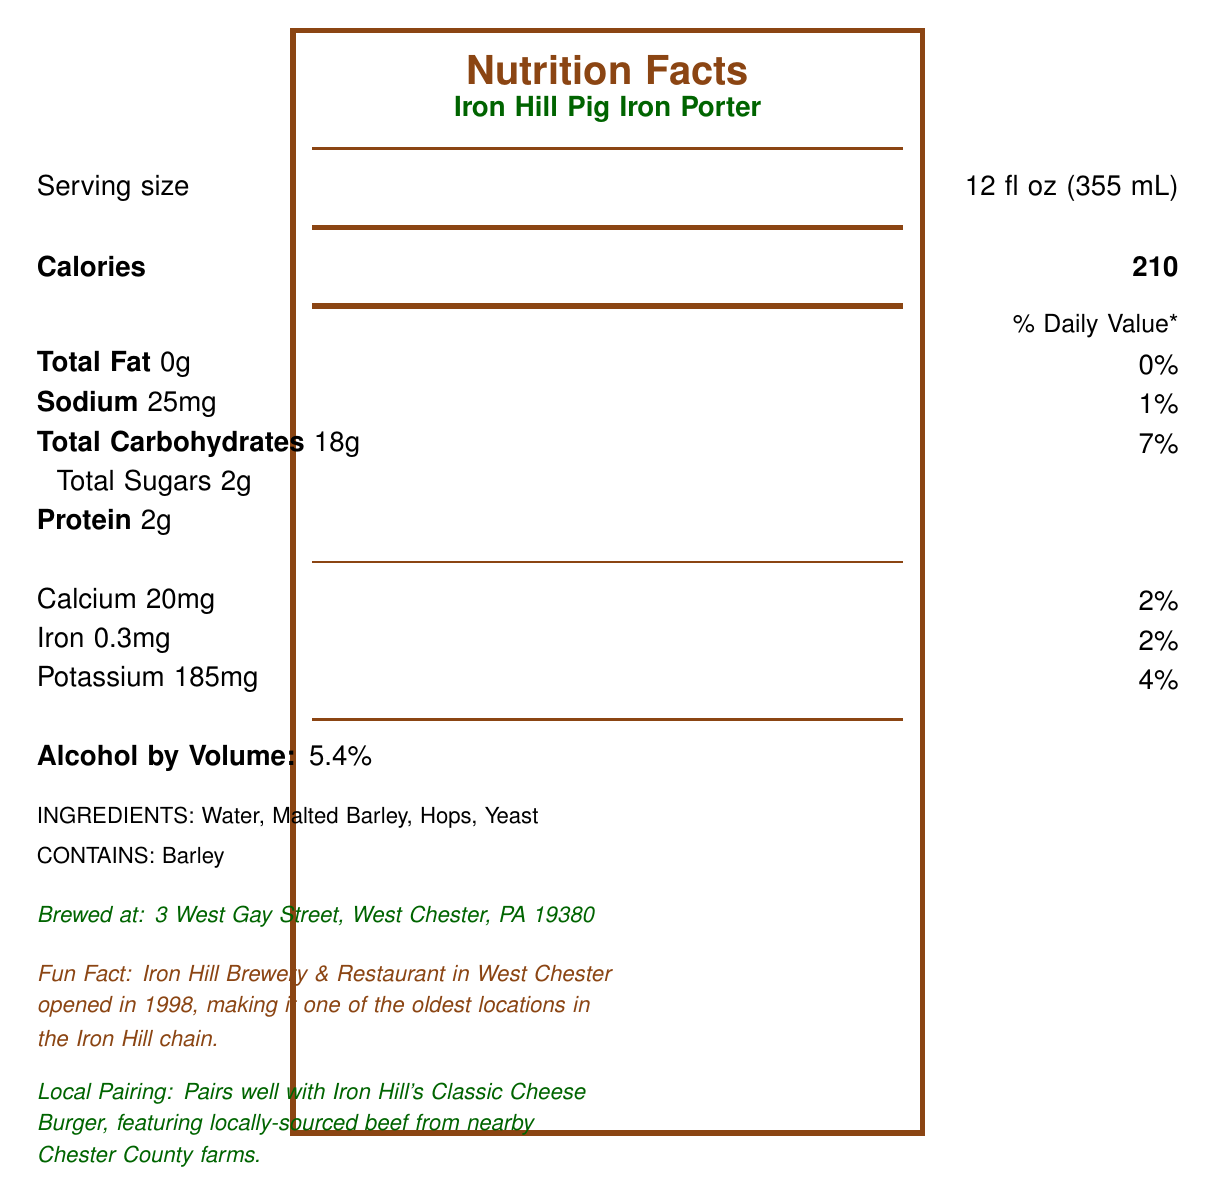What is the serving size of Iron Hill Pig Iron Porter? The serving size is explicitly mentioned in the document as "12 fl oz (355 mL)".
Answer: 12 fl oz (355 mL) How many calories are in one serving of Iron Hill Pig Iron Porter? The document states that there are 210 calories in one serving.
Answer: 210 What is the percentage of daily value for sodium? The document lists sodium content as 25mg, which is 1% of the daily value.
Answer: 1% How much protein does Iron Hill Pig Iron Porter have per serving? The document indicates that there are 2 grams of protein per serving.
Answer: 2g List all the ingredients in Iron Hill Pig Iron Porter. The ingredients are listed in the document as Water, Malted Barley, Hops, and Yeast.
Answer: Water, Malted Barley, Hops, Yeast What is the alcohol by volume (ABV) percentage of Iron Hill Pig Iron Porter? The document states that the alcohol by volume is 5.4%.
Answer: 5.4% Where is Iron Hill Brewery & Restaurant located in West Chester? The brewer's location is given as 3 West Gay Street, West Chester, PA 19380.
Answer: 3 West Gay Street, West Chester, PA 19380 Which nutrient contributes the most to the daily value percentage in Iron Hill Pig Iron Porter?
A) Total Fat
B) Sodium
C) Total Carbohydrates
D) Calcium Total Carbohydrates contribute 7% of the daily value, which is the highest among the listed nutrients.
Answer: C) Total Carbohydrates What fun fact is mentioned about Iron Hill Brewery in West Chester?
A) It is the largest location in the Iron Hill chain.
B) It opened in 1998.
C) It features organic ingredients.
D) It has a rooftop bar. The fun fact mentions that Iron Hill Brewery & Restaurant opened in 1998, making it one of the oldest locations in the Iron Hill chain.
Answer: B) It opened in 1998. Does Iron Hill Pig Iron Porter contain any allergens? The document states that it contains barley.
Answer: Yes Summarize the information provided in the Nutrition Facts Label. This summary covers the key information on the Nutrition Facts Label, including both nutritional content and supplementary details about the brewery.
Answer: The document provides nutritional information for Iron Hill Pig Iron Porter, including serving size, calories, amounts of various nutrients, ingredients, and allergen information. It also provides a fun fact about the brewery, its location in West Chester, PA, and a local pairing suggestion. What is the percentage of daily value for potassium in Iron Hill Pig Iron Porter? The document shows that the potassium content is 185mg, which is 4% of the daily value.
Answer: 4% How many grams of total sugars are in Iron Hill Pig Iron Porter? The document specifies that each serving contains 2 grams of total sugars.
Answer: 2g What is the recommendation for pairing Iron Hill Pig Iron Porter with local food? The document suggests pairing the beer with Iron Hill's Classic Cheese Burger made with locally-sourced beef.
Answer: Pairs well with Iron Hill's Classic Cheese Burger, featuring locally-sourced beef from nearby Chester County farms. What are the daily values percentages for calcium and iron in Iron Hill Pig Iron Porter? The document lists calcium as 20mg (2% of daily value) and iron as 0.3mg (2% of daily value).
Answer: Calcium: 2%, Iron: 2% What is the price of Iron Hill Pig Iron Porter? The document does not provide any information on the price of the product.
Answer: Not enough information 